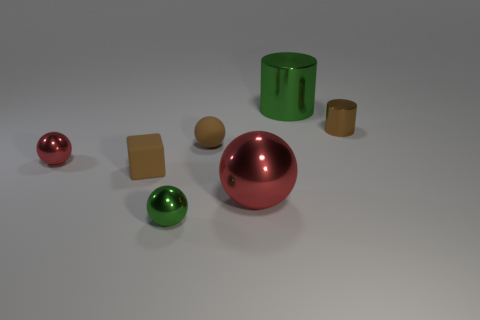Subtract 1 spheres. How many spheres are left? 3 Add 3 small brown rubber cylinders. How many objects exist? 10 Subtract all cubes. How many objects are left? 6 Add 6 large yellow cylinders. How many large yellow cylinders exist? 6 Subtract 1 brown spheres. How many objects are left? 6 Subtract all tiny brown rubber things. Subtract all tiny brown objects. How many objects are left? 2 Add 4 matte objects. How many matte objects are left? 6 